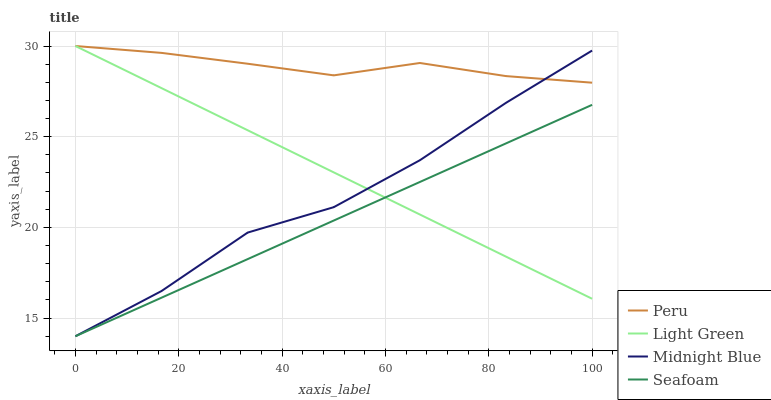Does Seafoam have the minimum area under the curve?
Answer yes or no. Yes. Does Peru have the maximum area under the curve?
Answer yes or no. Yes. Does Light Green have the minimum area under the curve?
Answer yes or no. No. Does Light Green have the maximum area under the curve?
Answer yes or no. No. Is Seafoam the smoothest?
Answer yes or no. Yes. Is Midnight Blue the roughest?
Answer yes or no. Yes. Is Peru the smoothest?
Answer yes or no. No. Is Peru the roughest?
Answer yes or no. No. Does Light Green have the lowest value?
Answer yes or no. No. Does Peru have the highest value?
Answer yes or no. Yes. Does Midnight Blue have the highest value?
Answer yes or no. No. Is Seafoam less than Peru?
Answer yes or no. Yes. Is Peru greater than Seafoam?
Answer yes or no. Yes. Does Seafoam intersect Midnight Blue?
Answer yes or no. Yes. Is Seafoam less than Midnight Blue?
Answer yes or no. No. Is Seafoam greater than Midnight Blue?
Answer yes or no. No. Does Seafoam intersect Peru?
Answer yes or no. No. 